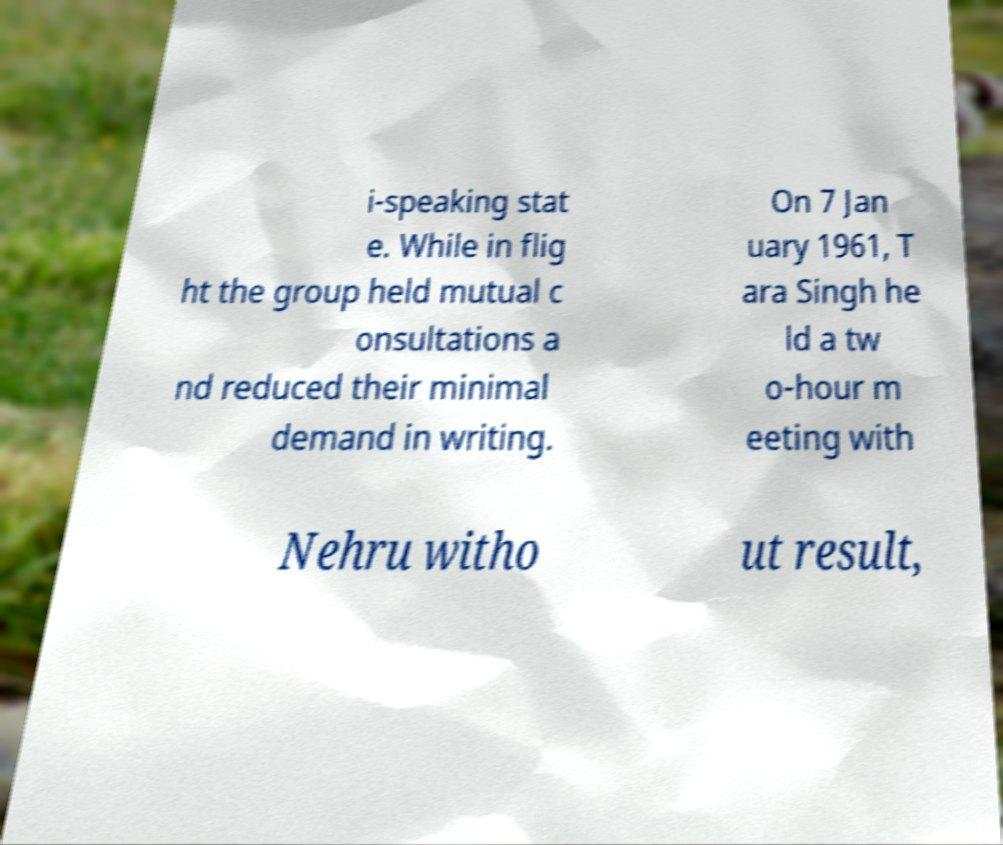Can you accurately transcribe the text from the provided image for me? i-speaking stat e. While in flig ht the group held mutual c onsultations a nd reduced their minimal demand in writing. On 7 Jan uary 1961, T ara Singh he ld a tw o-hour m eeting with Nehru witho ut result, 